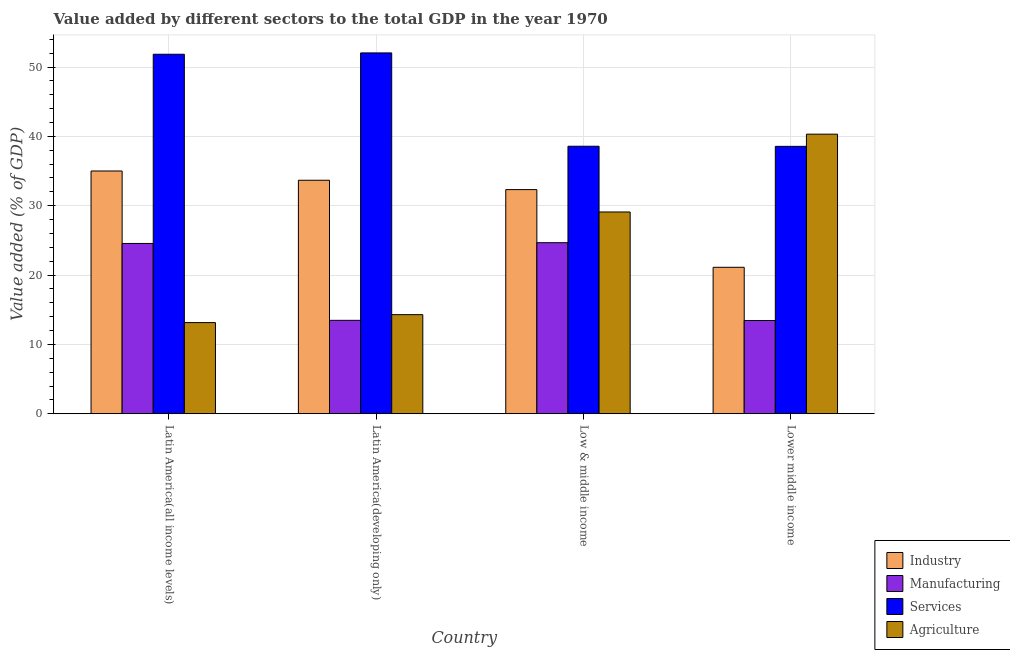Are the number of bars per tick equal to the number of legend labels?
Give a very brief answer. Yes. Are the number of bars on each tick of the X-axis equal?
Make the answer very short. Yes. How many bars are there on the 4th tick from the right?
Your answer should be compact. 4. What is the label of the 1st group of bars from the left?
Offer a very short reply. Latin America(all income levels). What is the value added by manufacturing sector in Latin America(all income levels)?
Your response must be concise. 24.56. Across all countries, what is the maximum value added by agricultural sector?
Make the answer very short. 40.32. Across all countries, what is the minimum value added by industrial sector?
Keep it short and to the point. 21.12. In which country was the value added by services sector maximum?
Offer a terse response. Latin America(developing only). In which country was the value added by agricultural sector minimum?
Ensure brevity in your answer.  Latin America(all income levels). What is the total value added by agricultural sector in the graph?
Provide a short and direct response. 96.86. What is the difference between the value added by agricultural sector in Latin America(all income levels) and that in Latin America(developing only)?
Ensure brevity in your answer.  -1.14. What is the difference between the value added by agricultural sector in Latin America(all income levels) and the value added by services sector in Low & middle income?
Ensure brevity in your answer.  -25.43. What is the average value added by industrial sector per country?
Give a very brief answer. 30.53. What is the difference between the value added by industrial sector and value added by services sector in Latin America(developing only)?
Give a very brief answer. -18.36. What is the ratio of the value added by services sector in Latin America(developing only) to that in Low & middle income?
Keep it short and to the point. 1.35. Is the value added by manufacturing sector in Latin America(all income levels) less than that in Latin America(developing only)?
Your answer should be very brief. No. Is the difference between the value added by manufacturing sector in Latin America(developing only) and Lower middle income greater than the difference between the value added by services sector in Latin America(developing only) and Lower middle income?
Provide a short and direct response. No. What is the difference between the highest and the second highest value added by manufacturing sector?
Offer a very short reply. 0.11. What is the difference between the highest and the lowest value added by industrial sector?
Provide a succinct answer. 13.89. Is the sum of the value added by manufacturing sector in Latin America(developing only) and Lower middle income greater than the maximum value added by industrial sector across all countries?
Ensure brevity in your answer.  No. What does the 3rd bar from the left in Low & middle income represents?
Give a very brief answer. Services. What does the 2nd bar from the right in Low & middle income represents?
Provide a short and direct response. Services. How many bars are there?
Your response must be concise. 16. Are all the bars in the graph horizontal?
Your answer should be compact. No. How many countries are there in the graph?
Your answer should be compact. 4. Where does the legend appear in the graph?
Your answer should be very brief. Bottom right. How many legend labels are there?
Offer a terse response. 4. What is the title of the graph?
Give a very brief answer. Value added by different sectors to the total GDP in the year 1970. Does "Building human resources" appear as one of the legend labels in the graph?
Provide a short and direct response. No. What is the label or title of the X-axis?
Ensure brevity in your answer.  Country. What is the label or title of the Y-axis?
Give a very brief answer. Value added (% of GDP). What is the Value added (% of GDP) of Industry in Latin America(all income levels)?
Give a very brief answer. 35.01. What is the Value added (% of GDP) of Manufacturing in Latin America(all income levels)?
Keep it short and to the point. 24.56. What is the Value added (% of GDP) in Services in Latin America(all income levels)?
Give a very brief answer. 51.84. What is the Value added (% of GDP) in Agriculture in Latin America(all income levels)?
Provide a short and direct response. 13.15. What is the Value added (% of GDP) of Industry in Latin America(developing only)?
Make the answer very short. 33.67. What is the Value added (% of GDP) of Manufacturing in Latin America(developing only)?
Ensure brevity in your answer.  13.47. What is the Value added (% of GDP) of Services in Latin America(developing only)?
Keep it short and to the point. 52.04. What is the Value added (% of GDP) of Agriculture in Latin America(developing only)?
Your response must be concise. 14.29. What is the Value added (% of GDP) of Industry in Low & middle income?
Keep it short and to the point. 32.33. What is the Value added (% of GDP) of Manufacturing in Low & middle income?
Offer a terse response. 24.67. What is the Value added (% of GDP) in Services in Low & middle income?
Ensure brevity in your answer.  38.58. What is the Value added (% of GDP) in Agriculture in Low & middle income?
Your answer should be compact. 29.1. What is the Value added (% of GDP) of Industry in Lower middle income?
Your answer should be compact. 21.12. What is the Value added (% of GDP) of Manufacturing in Lower middle income?
Ensure brevity in your answer.  13.44. What is the Value added (% of GDP) in Services in Lower middle income?
Offer a terse response. 38.56. What is the Value added (% of GDP) in Agriculture in Lower middle income?
Make the answer very short. 40.32. Across all countries, what is the maximum Value added (% of GDP) in Industry?
Your response must be concise. 35.01. Across all countries, what is the maximum Value added (% of GDP) in Manufacturing?
Keep it short and to the point. 24.67. Across all countries, what is the maximum Value added (% of GDP) of Services?
Provide a succinct answer. 52.04. Across all countries, what is the maximum Value added (% of GDP) of Agriculture?
Ensure brevity in your answer.  40.32. Across all countries, what is the minimum Value added (% of GDP) in Industry?
Your answer should be compact. 21.12. Across all countries, what is the minimum Value added (% of GDP) of Manufacturing?
Make the answer very short. 13.44. Across all countries, what is the minimum Value added (% of GDP) of Services?
Your answer should be very brief. 38.56. Across all countries, what is the minimum Value added (% of GDP) of Agriculture?
Give a very brief answer. 13.15. What is the total Value added (% of GDP) of Industry in the graph?
Your answer should be compact. 122.13. What is the total Value added (% of GDP) of Manufacturing in the graph?
Keep it short and to the point. 76.14. What is the total Value added (% of GDP) of Services in the graph?
Make the answer very short. 181.02. What is the total Value added (% of GDP) in Agriculture in the graph?
Provide a succinct answer. 96.86. What is the difference between the Value added (% of GDP) of Industry in Latin America(all income levels) and that in Latin America(developing only)?
Offer a very short reply. 1.34. What is the difference between the Value added (% of GDP) of Manufacturing in Latin America(all income levels) and that in Latin America(developing only)?
Your answer should be compact. 11.09. What is the difference between the Value added (% of GDP) in Services in Latin America(all income levels) and that in Latin America(developing only)?
Offer a terse response. -0.19. What is the difference between the Value added (% of GDP) of Agriculture in Latin America(all income levels) and that in Latin America(developing only)?
Keep it short and to the point. -1.14. What is the difference between the Value added (% of GDP) of Industry in Latin America(all income levels) and that in Low & middle income?
Ensure brevity in your answer.  2.68. What is the difference between the Value added (% of GDP) in Manufacturing in Latin America(all income levels) and that in Low & middle income?
Your answer should be very brief. -0.11. What is the difference between the Value added (% of GDP) in Services in Latin America(all income levels) and that in Low & middle income?
Offer a very short reply. 13.27. What is the difference between the Value added (% of GDP) of Agriculture in Latin America(all income levels) and that in Low & middle income?
Offer a terse response. -15.95. What is the difference between the Value added (% of GDP) of Industry in Latin America(all income levels) and that in Lower middle income?
Make the answer very short. 13.89. What is the difference between the Value added (% of GDP) of Manufacturing in Latin America(all income levels) and that in Lower middle income?
Your response must be concise. 11.11. What is the difference between the Value added (% of GDP) in Services in Latin America(all income levels) and that in Lower middle income?
Your response must be concise. 13.28. What is the difference between the Value added (% of GDP) in Agriculture in Latin America(all income levels) and that in Lower middle income?
Offer a very short reply. -27.17. What is the difference between the Value added (% of GDP) of Industry in Latin America(developing only) and that in Low & middle income?
Make the answer very short. 1.35. What is the difference between the Value added (% of GDP) of Manufacturing in Latin America(developing only) and that in Low & middle income?
Give a very brief answer. -11.2. What is the difference between the Value added (% of GDP) in Services in Latin America(developing only) and that in Low & middle income?
Offer a terse response. 13.46. What is the difference between the Value added (% of GDP) of Agriculture in Latin America(developing only) and that in Low & middle income?
Your answer should be compact. -14.81. What is the difference between the Value added (% of GDP) in Industry in Latin America(developing only) and that in Lower middle income?
Ensure brevity in your answer.  12.55. What is the difference between the Value added (% of GDP) in Manufacturing in Latin America(developing only) and that in Lower middle income?
Provide a short and direct response. 0.03. What is the difference between the Value added (% of GDP) of Services in Latin America(developing only) and that in Lower middle income?
Your answer should be compact. 13.48. What is the difference between the Value added (% of GDP) of Agriculture in Latin America(developing only) and that in Lower middle income?
Offer a very short reply. -26.03. What is the difference between the Value added (% of GDP) in Industry in Low & middle income and that in Lower middle income?
Ensure brevity in your answer.  11.21. What is the difference between the Value added (% of GDP) of Manufacturing in Low & middle income and that in Lower middle income?
Give a very brief answer. 11.22. What is the difference between the Value added (% of GDP) of Services in Low & middle income and that in Lower middle income?
Offer a very short reply. 0.02. What is the difference between the Value added (% of GDP) of Agriculture in Low & middle income and that in Lower middle income?
Your answer should be compact. -11.22. What is the difference between the Value added (% of GDP) of Industry in Latin America(all income levels) and the Value added (% of GDP) of Manufacturing in Latin America(developing only)?
Your response must be concise. 21.54. What is the difference between the Value added (% of GDP) of Industry in Latin America(all income levels) and the Value added (% of GDP) of Services in Latin America(developing only)?
Offer a terse response. -17.03. What is the difference between the Value added (% of GDP) in Industry in Latin America(all income levels) and the Value added (% of GDP) in Agriculture in Latin America(developing only)?
Provide a succinct answer. 20.72. What is the difference between the Value added (% of GDP) of Manufacturing in Latin America(all income levels) and the Value added (% of GDP) of Services in Latin America(developing only)?
Offer a very short reply. -27.48. What is the difference between the Value added (% of GDP) of Manufacturing in Latin America(all income levels) and the Value added (% of GDP) of Agriculture in Latin America(developing only)?
Keep it short and to the point. 10.27. What is the difference between the Value added (% of GDP) in Services in Latin America(all income levels) and the Value added (% of GDP) in Agriculture in Latin America(developing only)?
Give a very brief answer. 37.55. What is the difference between the Value added (% of GDP) in Industry in Latin America(all income levels) and the Value added (% of GDP) in Manufacturing in Low & middle income?
Your answer should be very brief. 10.34. What is the difference between the Value added (% of GDP) in Industry in Latin America(all income levels) and the Value added (% of GDP) in Services in Low & middle income?
Ensure brevity in your answer.  -3.57. What is the difference between the Value added (% of GDP) of Industry in Latin America(all income levels) and the Value added (% of GDP) of Agriculture in Low & middle income?
Offer a very short reply. 5.91. What is the difference between the Value added (% of GDP) of Manufacturing in Latin America(all income levels) and the Value added (% of GDP) of Services in Low & middle income?
Provide a short and direct response. -14.02. What is the difference between the Value added (% of GDP) in Manufacturing in Latin America(all income levels) and the Value added (% of GDP) in Agriculture in Low & middle income?
Your answer should be compact. -4.54. What is the difference between the Value added (% of GDP) of Services in Latin America(all income levels) and the Value added (% of GDP) of Agriculture in Low & middle income?
Offer a very short reply. 22.75. What is the difference between the Value added (% of GDP) in Industry in Latin America(all income levels) and the Value added (% of GDP) in Manufacturing in Lower middle income?
Ensure brevity in your answer.  21.56. What is the difference between the Value added (% of GDP) of Industry in Latin America(all income levels) and the Value added (% of GDP) of Services in Lower middle income?
Give a very brief answer. -3.55. What is the difference between the Value added (% of GDP) of Industry in Latin America(all income levels) and the Value added (% of GDP) of Agriculture in Lower middle income?
Ensure brevity in your answer.  -5.31. What is the difference between the Value added (% of GDP) of Manufacturing in Latin America(all income levels) and the Value added (% of GDP) of Services in Lower middle income?
Your response must be concise. -14. What is the difference between the Value added (% of GDP) of Manufacturing in Latin America(all income levels) and the Value added (% of GDP) of Agriculture in Lower middle income?
Provide a succinct answer. -15.76. What is the difference between the Value added (% of GDP) of Services in Latin America(all income levels) and the Value added (% of GDP) of Agriculture in Lower middle income?
Give a very brief answer. 11.52. What is the difference between the Value added (% of GDP) in Industry in Latin America(developing only) and the Value added (% of GDP) in Manufacturing in Low & middle income?
Offer a very short reply. 9. What is the difference between the Value added (% of GDP) in Industry in Latin America(developing only) and the Value added (% of GDP) in Services in Low & middle income?
Keep it short and to the point. -4.9. What is the difference between the Value added (% of GDP) of Industry in Latin America(developing only) and the Value added (% of GDP) of Agriculture in Low & middle income?
Your answer should be compact. 4.57. What is the difference between the Value added (% of GDP) in Manufacturing in Latin America(developing only) and the Value added (% of GDP) in Services in Low & middle income?
Give a very brief answer. -25.11. What is the difference between the Value added (% of GDP) in Manufacturing in Latin America(developing only) and the Value added (% of GDP) in Agriculture in Low & middle income?
Your answer should be compact. -15.63. What is the difference between the Value added (% of GDP) of Services in Latin America(developing only) and the Value added (% of GDP) of Agriculture in Low & middle income?
Your answer should be compact. 22.94. What is the difference between the Value added (% of GDP) in Industry in Latin America(developing only) and the Value added (% of GDP) in Manufacturing in Lower middle income?
Make the answer very short. 20.23. What is the difference between the Value added (% of GDP) in Industry in Latin America(developing only) and the Value added (% of GDP) in Services in Lower middle income?
Offer a terse response. -4.89. What is the difference between the Value added (% of GDP) of Industry in Latin America(developing only) and the Value added (% of GDP) of Agriculture in Lower middle income?
Keep it short and to the point. -6.65. What is the difference between the Value added (% of GDP) of Manufacturing in Latin America(developing only) and the Value added (% of GDP) of Services in Lower middle income?
Make the answer very short. -25.09. What is the difference between the Value added (% of GDP) in Manufacturing in Latin America(developing only) and the Value added (% of GDP) in Agriculture in Lower middle income?
Give a very brief answer. -26.85. What is the difference between the Value added (% of GDP) in Services in Latin America(developing only) and the Value added (% of GDP) in Agriculture in Lower middle income?
Provide a short and direct response. 11.72. What is the difference between the Value added (% of GDP) of Industry in Low & middle income and the Value added (% of GDP) of Manufacturing in Lower middle income?
Offer a very short reply. 18.88. What is the difference between the Value added (% of GDP) in Industry in Low & middle income and the Value added (% of GDP) in Services in Lower middle income?
Provide a succinct answer. -6.24. What is the difference between the Value added (% of GDP) in Industry in Low & middle income and the Value added (% of GDP) in Agriculture in Lower middle income?
Provide a short and direct response. -7.99. What is the difference between the Value added (% of GDP) in Manufacturing in Low & middle income and the Value added (% of GDP) in Services in Lower middle income?
Provide a succinct answer. -13.89. What is the difference between the Value added (% of GDP) in Manufacturing in Low & middle income and the Value added (% of GDP) in Agriculture in Lower middle income?
Provide a short and direct response. -15.65. What is the difference between the Value added (% of GDP) in Services in Low & middle income and the Value added (% of GDP) in Agriculture in Lower middle income?
Give a very brief answer. -1.74. What is the average Value added (% of GDP) of Industry per country?
Offer a terse response. 30.53. What is the average Value added (% of GDP) of Manufacturing per country?
Offer a terse response. 19.04. What is the average Value added (% of GDP) of Services per country?
Make the answer very short. 45.25. What is the average Value added (% of GDP) of Agriculture per country?
Make the answer very short. 24.21. What is the difference between the Value added (% of GDP) in Industry and Value added (% of GDP) in Manufacturing in Latin America(all income levels)?
Your response must be concise. 10.45. What is the difference between the Value added (% of GDP) in Industry and Value added (% of GDP) in Services in Latin America(all income levels)?
Provide a short and direct response. -16.83. What is the difference between the Value added (% of GDP) in Industry and Value added (% of GDP) in Agriculture in Latin America(all income levels)?
Ensure brevity in your answer.  21.86. What is the difference between the Value added (% of GDP) of Manufacturing and Value added (% of GDP) of Services in Latin America(all income levels)?
Make the answer very short. -27.29. What is the difference between the Value added (% of GDP) of Manufacturing and Value added (% of GDP) of Agriculture in Latin America(all income levels)?
Ensure brevity in your answer.  11.41. What is the difference between the Value added (% of GDP) of Services and Value added (% of GDP) of Agriculture in Latin America(all income levels)?
Give a very brief answer. 38.7. What is the difference between the Value added (% of GDP) in Industry and Value added (% of GDP) in Manufacturing in Latin America(developing only)?
Ensure brevity in your answer.  20.2. What is the difference between the Value added (% of GDP) in Industry and Value added (% of GDP) in Services in Latin America(developing only)?
Your response must be concise. -18.36. What is the difference between the Value added (% of GDP) in Industry and Value added (% of GDP) in Agriculture in Latin America(developing only)?
Give a very brief answer. 19.38. What is the difference between the Value added (% of GDP) in Manufacturing and Value added (% of GDP) in Services in Latin America(developing only)?
Offer a terse response. -38.57. What is the difference between the Value added (% of GDP) of Manufacturing and Value added (% of GDP) of Agriculture in Latin America(developing only)?
Make the answer very short. -0.82. What is the difference between the Value added (% of GDP) in Services and Value added (% of GDP) in Agriculture in Latin America(developing only)?
Provide a succinct answer. 37.75. What is the difference between the Value added (% of GDP) of Industry and Value added (% of GDP) of Manufacturing in Low & middle income?
Your answer should be very brief. 7.66. What is the difference between the Value added (% of GDP) of Industry and Value added (% of GDP) of Services in Low & middle income?
Offer a terse response. -6.25. What is the difference between the Value added (% of GDP) of Industry and Value added (% of GDP) of Agriculture in Low & middle income?
Keep it short and to the point. 3.23. What is the difference between the Value added (% of GDP) of Manufacturing and Value added (% of GDP) of Services in Low & middle income?
Keep it short and to the point. -13.91. What is the difference between the Value added (% of GDP) of Manufacturing and Value added (% of GDP) of Agriculture in Low & middle income?
Provide a succinct answer. -4.43. What is the difference between the Value added (% of GDP) in Services and Value added (% of GDP) in Agriculture in Low & middle income?
Give a very brief answer. 9.48. What is the difference between the Value added (% of GDP) in Industry and Value added (% of GDP) in Manufacturing in Lower middle income?
Give a very brief answer. 7.68. What is the difference between the Value added (% of GDP) in Industry and Value added (% of GDP) in Services in Lower middle income?
Ensure brevity in your answer.  -17.44. What is the difference between the Value added (% of GDP) in Industry and Value added (% of GDP) in Agriculture in Lower middle income?
Your response must be concise. -19.2. What is the difference between the Value added (% of GDP) in Manufacturing and Value added (% of GDP) in Services in Lower middle income?
Provide a short and direct response. -25.12. What is the difference between the Value added (% of GDP) of Manufacturing and Value added (% of GDP) of Agriculture in Lower middle income?
Your answer should be very brief. -26.88. What is the difference between the Value added (% of GDP) of Services and Value added (% of GDP) of Agriculture in Lower middle income?
Provide a short and direct response. -1.76. What is the ratio of the Value added (% of GDP) in Industry in Latin America(all income levels) to that in Latin America(developing only)?
Provide a succinct answer. 1.04. What is the ratio of the Value added (% of GDP) in Manufacturing in Latin America(all income levels) to that in Latin America(developing only)?
Provide a short and direct response. 1.82. What is the ratio of the Value added (% of GDP) of Industry in Latin America(all income levels) to that in Low & middle income?
Your answer should be very brief. 1.08. What is the ratio of the Value added (% of GDP) in Manufacturing in Latin America(all income levels) to that in Low & middle income?
Provide a short and direct response. 1. What is the ratio of the Value added (% of GDP) of Services in Latin America(all income levels) to that in Low & middle income?
Offer a very short reply. 1.34. What is the ratio of the Value added (% of GDP) in Agriculture in Latin America(all income levels) to that in Low & middle income?
Make the answer very short. 0.45. What is the ratio of the Value added (% of GDP) in Industry in Latin America(all income levels) to that in Lower middle income?
Offer a terse response. 1.66. What is the ratio of the Value added (% of GDP) of Manufacturing in Latin America(all income levels) to that in Lower middle income?
Offer a very short reply. 1.83. What is the ratio of the Value added (% of GDP) of Services in Latin America(all income levels) to that in Lower middle income?
Your answer should be very brief. 1.34. What is the ratio of the Value added (% of GDP) in Agriculture in Latin America(all income levels) to that in Lower middle income?
Make the answer very short. 0.33. What is the ratio of the Value added (% of GDP) in Industry in Latin America(developing only) to that in Low & middle income?
Keep it short and to the point. 1.04. What is the ratio of the Value added (% of GDP) of Manufacturing in Latin America(developing only) to that in Low & middle income?
Your response must be concise. 0.55. What is the ratio of the Value added (% of GDP) in Services in Latin America(developing only) to that in Low & middle income?
Your answer should be compact. 1.35. What is the ratio of the Value added (% of GDP) in Agriculture in Latin America(developing only) to that in Low & middle income?
Offer a terse response. 0.49. What is the ratio of the Value added (% of GDP) of Industry in Latin America(developing only) to that in Lower middle income?
Offer a very short reply. 1.59. What is the ratio of the Value added (% of GDP) in Manufacturing in Latin America(developing only) to that in Lower middle income?
Provide a succinct answer. 1. What is the ratio of the Value added (% of GDP) of Services in Latin America(developing only) to that in Lower middle income?
Give a very brief answer. 1.35. What is the ratio of the Value added (% of GDP) of Agriculture in Latin America(developing only) to that in Lower middle income?
Your answer should be compact. 0.35. What is the ratio of the Value added (% of GDP) of Industry in Low & middle income to that in Lower middle income?
Offer a terse response. 1.53. What is the ratio of the Value added (% of GDP) of Manufacturing in Low & middle income to that in Lower middle income?
Provide a succinct answer. 1.83. What is the ratio of the Value added (% of GDP) of Agriculture in Low & middle income to that in Lower middle income?
Your response must be concise. 0.72. What is the difference between the highest and the second highest Value added (% of GDP) of Industry?
Offer a very short reply. 1.34. What is the difference between the highest and the second highest Value added (% of GDP) of Manufacturing?
Keep it short and to the point. 0.11. What is the difference between the highest and the second highest Value added (% of GDP) in Services?
Your response must be concise. 0.19. What is the difference between the highest and the second highest Value added (% of GDP) of Agriculture?
Give a very brief answer. 11.22. What is the difference between the highest and the lowest Value added (% of GDP) in Industry?
Give a very brief answer. 13.89. What is the difference between the highest and the lowest Value added (% of GDP) in Manufacturing?
Offer a terse response. 11.22. What is the difference between the highest and the lowest Value added (% of GDP) in Services?
Offer a very short reply. 13.48. What is the difference between the highest and the lowest Value added (% of GDP) in Agriculture?
Offer a very short reply. 27.17. 